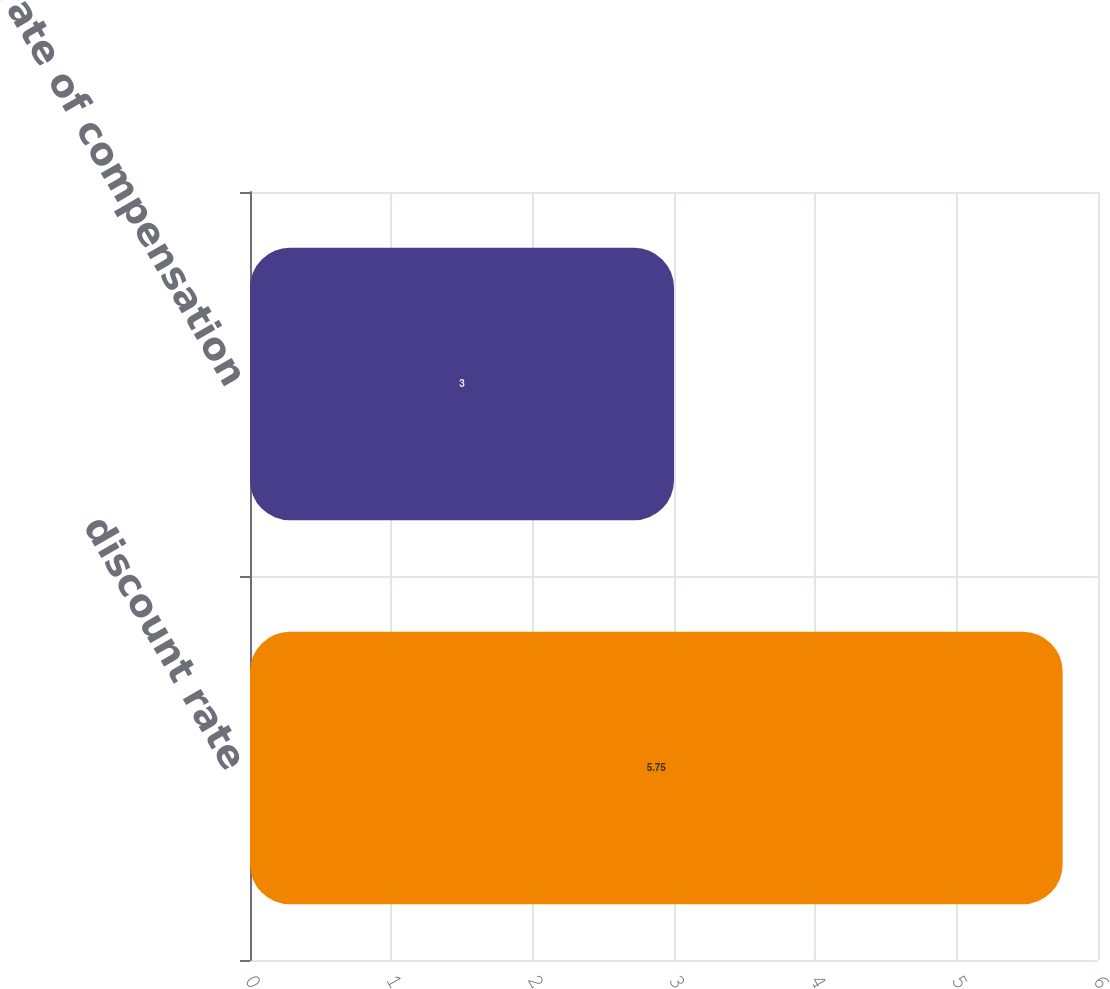Convert chart. <chart><loc_0><loc_0><loc_500><loc_500><bar_chart><fcel>discount rate<fcel>long-term rate of compensation<nl><fcel>5.75<fcel>3<nl></chart> 